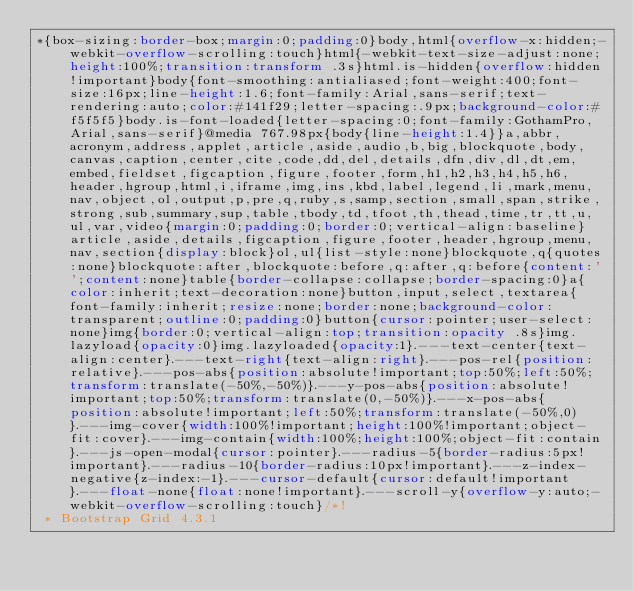Convert code to text. <code><loc_0><loc_0><loc_500><loc_500><_CSS_>*{box-sizing:border-box;margin:0;padding:0}body,html{overflow-x:hidden;-webkit-overflow-scrolling:touch}html{-webkit-text-size-adjust:none;height:100%;transition:transform .3s}html.is-hidden{overflow:hidden!important}body{font-smoothing:antialiased;font-weight:400;font-size:16px;line-height:1.6;font-family:Arial,sans-serif;text-rendering:auto;color:#141f29;letter-spacing:.9px;background-color:#f5f5f5}body.is-font-loaded{letter-spacing:0;font-family:GothamPro,Arial,sans-serif}@media 767.98px{body{line-height:1.4}}a,abbr,acronym,address,applet,article,aside,audio,b,big,blockquote,body,canvas,caption,center,cite,code,dd,del,details,dfn,div,dl,dt,em,embed,fieldset,figcaption,figure,footer,form,h1,h2,h3,h4,h5,h6,header,hgroup,html,i,iframe,img,ins,kbd,label,legend,li,mark,menu,nav,object,ol,output,p,pre,q,ruby,s,samp,section,small,span,strike,strong,sub,summary,sup,table,tbody,td,tfoot,th,thead,time,tr,tt,u,ul,var,video{margin:0;padding:0;border:0;vertical-align:baseline}article,aside,details,figcaption,figure,footer,header,hgroup,menu,nav,section{display:block}ol,ul{list-style:none}blockquote,q{quotes:none}blockquote:after,blockquote:before,q:after,q:before{content:'';content:none}table{border-collapse:collapse;border-spacing:0}a{color:inherit;text-decoration:none}button,input,select,textarea{font-family:inherit;resize:none;border:none;background-color:transparent;outline:0;padding:0}button{cursor:pointer;user-select:none}img{border:0;vertical-align:top;transition:opacity .8s}img.lazyload{opacity:0}img.lazyloaded{opacity:1}.---text-center{text-align:center}.---text-right{text-align:right}.---pos-rel{position:relative}.---pos-abs{position:absolute!important;top:50%;left:50%;transform:translate(-50%,-50%)}.---y-pos-abs{position:absolute!important;top:50%;transform:translate(0,-50%)}.---x-pos-abs{position:absolute!important;left:50%;transform:translate(-50%,0)}.---img-cover{width:100%!important;height:100%!important;object-fit:cover}.---img-contain{width:100%;height:100%;object-fit:contain}.---js-open-modal{cursor:pointer}.---radius-5{border-radius:5px!important}.---radius-10{border-radius:10px!important}.---z-index-negative{z-index:-1}.---cursor-default{cursor:default!important}.---float-none{float:none!important}.---scroll-y{overflow-y:auto;-webkit-overflow-scrolling:touch}/*!
 * Bootstrap Grid 4.3.1</code> 